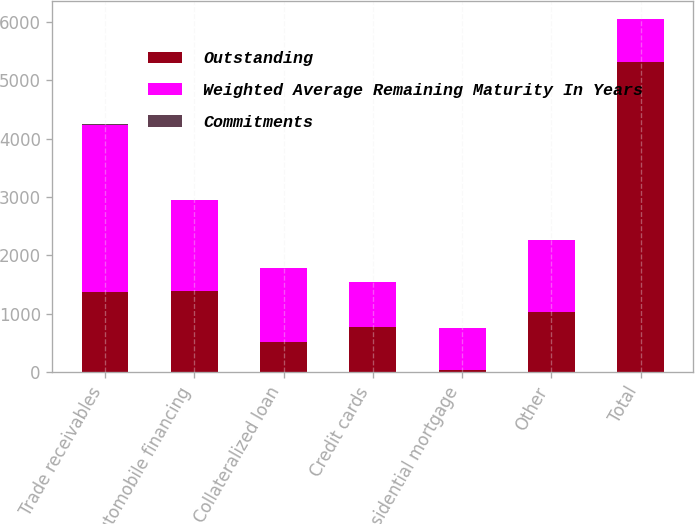Convert chart. <chart><loc_0><loc_0><loc_500><loc_500><stacked_bar_chart><ecel><fcel>Trade receivables<fcel>Automobile financing<fcel>Collateralized loan<fcel>Credit cards<fcel>Residential mortgage<fcel>Other<fcel>Total<nl><fcel>Outstanding<fcel>1375<fcel>1387<fcel>519<fcel>769<fcel>37<fcel>1031<fcel>5304<nl><fcel>Weighted Average Remaining Maturity In Years<fcel>2865<fcel>1565<fcel>1257<fcel>775<fcel>720<fcel>1224<fcel>744.5<nl><fcel>Commitments<fcel>2.63<fcel>4.06<fcel>2.54<fcel>0.26<fcel>0.9<fcel>1.89<fcel>2.41<nl></chart> 